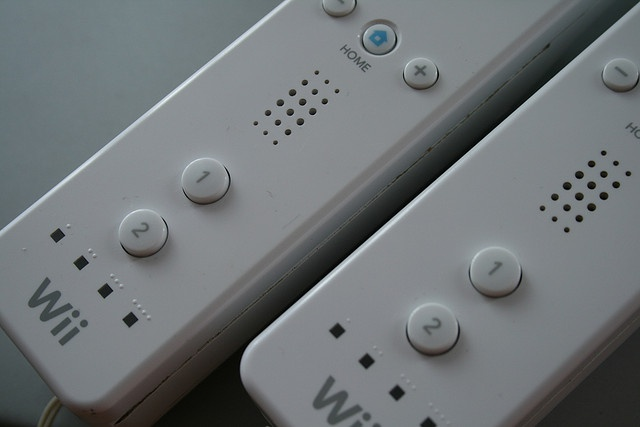Describe the objects in this image and their specific colors. I can see remote in gray and black tones and remote in gray tones in this image. 